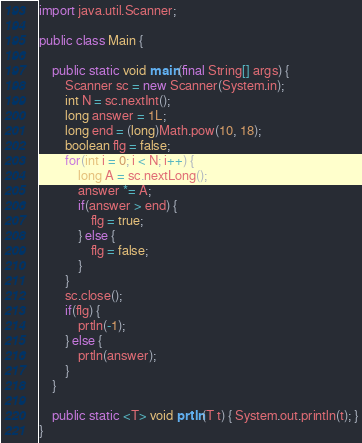Convert code to text. <code><loc_0><loc_0><loc_500><loc_500><_Java_>import java.util.Scanner;

public class Main {

	public static void main(final String[] args) {
		Scanner sc = new Scanner(System.in);
		int N = sc.nextInt();
		long answer = 1L;
		long end = (long)Math.pow(10, 18);
		boolean flg = false;
		for(int i = 0; i < N; i++) {
			long A = sc.nextLong();
			answer *= A;
			if(answer > end) {
				flg = true;
			} else {
				flg = false;
			}
		}
		sc.close();
		if(flg) {
			prtln(-1);
		} else {
			prtln(answer);
		}
	}

	public static <T> void prtln(T t) { System.out.println(t); }
}</code> 